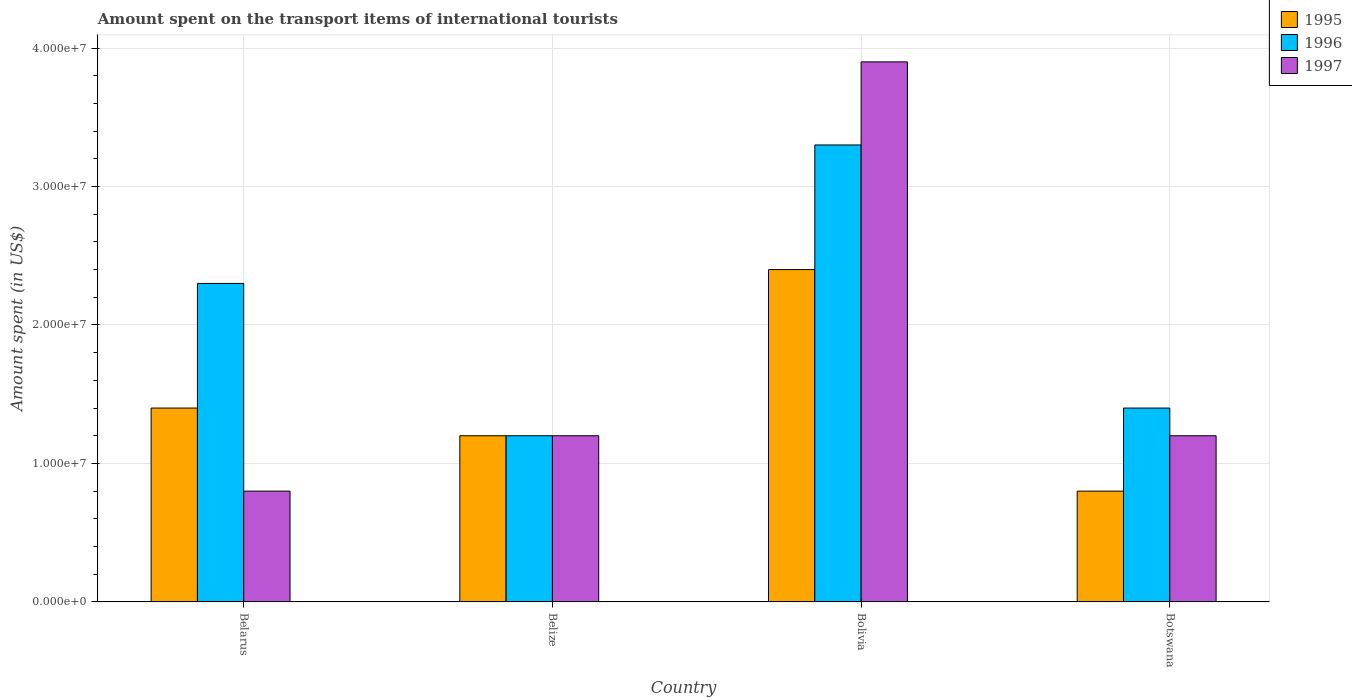How many different coloured bars are there?
Provide a succinct answer. 3. Are the number of bars per tick equal to the number of legend labels?
Your answer should be compact. Yes. How many bars are there on the 1st tick from the left?
Give a very brief answer. 3. What is the label of the 3rd group of bars from the left?
Your answer should be very brief. Bolivia. In how many cases, is the number of bars for a given country not equal to the number of legend labels?
Your answer should be compact. 0. What is the amount spent on the transport items of international tourists in 1997 in Bolivia?
Give a very brief answer. 3.90e+07. Across all countries, what is the maximum amount spent on the transport items of international tourists in 1996?
Your response must be concise. 3.30e+07. In which country was the amount spent on the transport items of international tourists in 1997 minimum?
Provide a succinct answer. Belarus. What is the total amount spent on the transport items of international tourists in 1997 in the graph?
Provide a succinct answer. 7.10e+07. What is the difference between the amount spent on the transport items of international tourists in 1997 in Belarus and that in Bolivia?
Your response must be concise. -3.10e+07. What is the difference between the amount spent on the transport items of international tourists in 1997 in Belarus and the amount spent on the transport items of international tourists in 1996 in Bolivia?
Your answer should be very brief. -2.50e+07. What is the average amount spent on the transport items of international tourists in 1997 per country?
Provide a succinct answer. 1.78e+07. What is the ratio of the amount spent on the transport items of international tourists in 1997 in Belarus to that in Belize?
Make the answer very short. 0.67. Is the amount spent on the transport items of international tourists in 1997 in Belarus less than that in Botswana?
Offer a very short reply. Yes. Is the difference between the amount spent on the transport items of international tourists in 1995 in Bolivia and Botswana greater than the difference between the amount spent on the transport items of international tourists in 1997 in Bolivia and Botswana?
Your response must be concise. No. What is the difference between the highest and the second highest amount spent on the transport items of international tourists in 1997?
Offer a terse response. 2.70e+07. What is the difference between the highest and the lowest amount spent on the transport items of international tourists in 1995?
Ensure brevity in your answer.  1.60e+07. Is the sum of the amount spent on the transport items of international tourists in 1996 in Belize and Bolivia greater than the maximum amount spent on the transport items of international tourists in 1997 across all countries?
Your answer should be very brief. Yes. What does the 2nd bar from the left in Botswana represents?
Offer a terse response. 1996. How many bars are there?
Give a very brief answer. 12. Are all the bars in the graph horizontal?
Make the answer very short. No. How many countries are there in the graph?
Make the answer very short. 4. Does the graph contain any zero values?
Offer a terse response. No. How many legend labels are there?
Give a very brief answer. 3. How are the legend labels stacked?
Your answer should be very brief. Vertical. What is the title of the graph?
Keep it short and to the point. Amount spent on the transport items of international tourists. Does "1990" appear as one of the legend labels in the graph?
Keep it short and to the point. No. What is the label or title of the Y-axis?
Offer a terse response. Amount spent (in US$). What is the Amount spent (in US$) of 1995 in Belarus?
Make the answer very short. 1.40e+07. What is the Amount spent (in US$) in 1996 in Belarus?
Your answer should be compact. 2.30e+07. What is the Amount spent (in US$) in 1997 in Belarus?
Provide a succinct answer. 8.00e+06. What is the Amount spent (in US$) of 1995 in Belize?
Keep it short and to the point. 1.20e+07. What is the Amount spent (in US$) in 1995 in Bolivia?
Offer a very short reply. 2.40e+07. What is the Amount spent (in US$) in 1996 in Bolivia?
Ensure brevity in your answer.  3.30e+07. What is the Amount spent (in US$) in 1997 in Bolivia?
Offer a terse response. 3.90e+07. What is the Amount spent (in US$) in 1995 in Botswana?
Provide a succinct answer. 8.00e+06. What is the Amount spent (in US$) in 1996 in Botswana?
Make the answer very short. 1.40e+07. Across all countries, what is the maximum Amount spent (in US$) in 1995?
Your answer should be very brief. 2.40e+07. Across all countries, what is the maximum Amount spent (in US$) in 1996?
Ensure brevity in your answer.  3.30e+07. Across all countries, what is the maximum Amount spent (in US$) in 1997?
Offer a very short reply. 3.90e+07. Across all countries, what is the minimum Amount spent (in US$) of 1996?
Give a very brief answer. 1.20e+07. What is the total Amount spent (in US$) in 1995 in the graph?
Ensure brevity in your answer.  5.80e+07. What is the total Amount spent (in US$) of 1996 in the graph?
Offer a terse response. 8.20e+07. What is the total Amount spent (in US$) in 1997 in the graph?
Make the answer very short. 7.10e+07. What is the difference between the Amount spent (in US$) in 1996 in Belarus and that in Belize?
Offer a very short reply. 1.10e+07. What is the difference between the Amount spent (in US$) of 1995 in Belarus and that in Bolivia?
Make the answer very short. -1.00e+07. What is the difference between the Amount spent (in US$) of 1996 in Belarus and that in Bolivia?
Ensure brevity in your answer.  -1.00e+07. What is the difference between the Amount spent (in US$) of 1997 in Belarus and that in Bolivia?
Keep it short and to the point. -3.10e+07. What is the difference between the Amount spent (in US$) of 1995 in Belarus and that in Botswana?
Make the answer very short. 6.00e+06. What is the difference between the Amount spent (in US$) in 1996 in Belarus and that in Botswana?
Offer a very short reply. 9.00e+06. What is the difference between the Amount spent (in US$) in 1995 in Belize and that in Bolivia?
Make the answer very short. -1.20e+07. What is the difference between the Amount spent (in US$) in 1996 in Belize and that in Bolivia?
Your answer should be very brief. -2.10e+07. What is the difference between the Amount spent (in US$) of 1997 in Belize and that in Bolivia?
Provide a short and direct response. -2.70e+07. What is the difference between the Amount spent (in US$) in 1997 in Belize and that in Botswana?
Make the answer very short. 0. What is the difference between the Amount spent (in US$) of 1995 in Bolivia and that in Botswana?
Your answer should be compact. 1.60e+07. What is the difference between the Amount spent (in US$) of 1996 in Bolivia and that in Botswana?
Offer a terse response. 1.90e+07. What is the difference between the Amount spent (in US$) of 1997 in Bolivia and that in Botswana?
Keep it short and to the point. 2.70e+07. What is the difference between the Amount spent (in US$) of 1995 in Belarus and the Amount spent (in US$) of 1996 in Belize?
Keep it short and to the point. 2.00e+06. What is the difference between the Amount spent (in US$) in 1995 in Belarus and the Amount spent (in US$) in 1997 in Belize?
Give a very brief answer. 2.00e+06. What is the difference between the Amount spent (in US$) of 1996 in Belarus and the Amount spent (in US$) of 1997 in Belize?
Provide a succinct answer. 1.10e+07. What is the difference between the Amount spent (in US$) of 1995 in Belarus and the Amount spent (in US$) of 1996 in Bolivia?
Keep it short and to the point. -1.90e+07. What is the difference between the Amount spent (in US$) of 1995 in Belarus and the Amount spent (in US$) of 1997 in Bolivia?
Provide a succinct answer. -2.50e+07. What is the difference between the Amount spent (in US$) of 1996 in Belarus and the Amount spent (in US$) of 1997 in Bolivia?
Ensure brevity in your answer.  -1.60e+07. What is the difference between the Amount spent (in US$) of 1996 in Belarus and the Amount spent (in US$) of 1997 in Botswana?
Ensure brevity in your answer.  1.10e+07. What is the difference between the Amount spent (in US$) in 1995 in Belize and the Amount spent (in US$) in 1996 in Bolivia?
Your answer should be very brief. -2.10e+07. What is the difference between the Amount spent (in US$) in 1995 in Belize and the Amount spent (in US$) in 1997 in Bolivia?
Make the answer very short. -2.70e+07. What is the difference between the Amount spent (in US$) of 1996 in Belize and the Amount spent (in US$) of 1997 in Bolivia?
Your answer should be compact. -2.70e+07. What is the difference between the Amount spent (in US$) in 1996 in Belize and the Amount spent (in US$) in 1997 in Botswana?
Offer a very short reply. 0. What is the difference between the Amount spent (in US$) of 1995 in Bolivia and the Amount spent (in US$) of 1996 in Botswana?
Keep it short and to the point. 1.00e+07. What is the difference between the Amount spent (in US$) of 1995 in Bolivia and the Amount spent (in US$) of 1997 in Botswana?
Offer a terse response. 1.20e+07. What is the difference between the Amount spent (in US$) of 1996 in Bolivia and the Amount spent (in US$) of 1997 in Botswana?
Your response must be concise. 2.10e+07. What is the average Amount spent (in US$) of 1995 per country?
Offer a very short reply. 1.45e+07. What is the average Amount spent (in US$) in 1996 per country?
Provide a succinct answer. 2.05e+07. What is the average Amount spent (in US$) in 1997 per country?
Ensure brevity in your answer.  1.78e+07. What is the difference between the Amount spent (in US$) in 1995 and Amount spent (in US$) in 1996 in Belarus?
Make the answer very short. -9.00e+06. What is the difference between the Amount spent (in US$) of 1995 and Amount spent (in US$) of 1997 in Belarus?
Provide a short and direct response. 6.00e+06. What is the difference between the Amount spent (in US$) in 1996 and Amount spent (in US$) in 1997 in Belarus?
Offer a terse response. 1.50e+07. What is the difference between the Amount spent (in US$) of 1995 and Amount spent (in US$) of 1996 in Belize?
Provide a short and direct response. 0. What is the difference between the Amount spent (in US$) of 1995 and Amount spent (in US$) of 1996 in Bolivia?
Give a very brief answer. -9.00e+06. What is the difference between the Amount spent (in US$) in 1995 and Amount spent (in US$) in 1997 in Bolivia?
Make the answer very short. -1.50e+07. What is the difference between the Amount spent (in US$) in 1996 and Amount spent (in US$) in 1997 in Bolivia?
Give a very brief answer. -6.00e+06. What is the difference between the Amount spent (in US$) in 1995 and Amount spent (in US$) in 1996 in Botswana?
Give a very brief answer. -6.00e+06. What is the difference between the Amount spent (in US$) of 1996 and Amount spent (in US$) of 1997 in Botswana?
Provide a succinct answer. 2.00e+06. What is the ratio of the Amount spent (in US$) of 1996 in Belarus to that in Belize?
Your answer should be compact. 1.92. What is the ratio of the Amount spent (in US$) in 1997 in Belarus to that in Belize?
Provide a succinct answer. 0.67. What is the ratio of the Amount spent (in US$) in 1995 in Belarus to that in Bolivia?
Provide a succinct answer. 0.58. What is the ratio of the Amount spent (in US$) of 1996 in Belarus to that in Bolivia?
Provide a succinct answer. 0.7. What is the ratio of the Amount spent (in US$) of 1997 in Belarus to that in Bolivia?
Offer a very short reply. 0.21. What is the ratio of the Amount spent (in US$) in 1996 in Belarus to that in Botswana?
Provide a short and direct response. 1.64. What is the ratio of the Amount spent (in US$) of 1997 in Belarus to that in Botswana?
Provide a short and direct response. 0.67. What is the ratio of the Amount spent (in US$) of 1996 in Belize to that in Bolivia?
Your answer should be very brief. 0.36. What is the ratio of the Amount spent (in US$) in 1997 in Belize to that in Bolivia?
Your response must be concise. 0.31. What is the ratio of the Amount spent (in US$) of 1995 in Belize to that in Botswana?
Your response must be concise. 1.5. What is the ratio of the Amount spent (in US$) of 1996 in Belize to that in Botswana?
Give a very brief answer. 0.86. What is the ratio of the Amount spent (in US$) in 1997 in Belize to that in Botswana?
Keep it short and to the point. 1. What is the ratio of the Amount spent (in US$) of 1996 in Bolivia to that in Botswana?
Your answer should be very brief. 2.36. What is the difference between the highest and the second highest Amount spent (in US$) of 1995?
Offer a terse response. 1.00e+07. What is the difference between the highest and the second highest Amount spent (in US$) of 1997?
Offer a very short reply. 2.70e+07. What is the difference between the highest and the lowest Amount spent (in US$) in 1995?
Your answer should be very brief. 1.60e+07. What is the difference between the highest and the lowest Amount spent (in US$) in 1996?
Your response must be concise. 2.10e+07. What is the difference between the highest and the lowest Amount spent (in US$) of 1997?
Ensure brevity in your answer.  3.10e+07. 